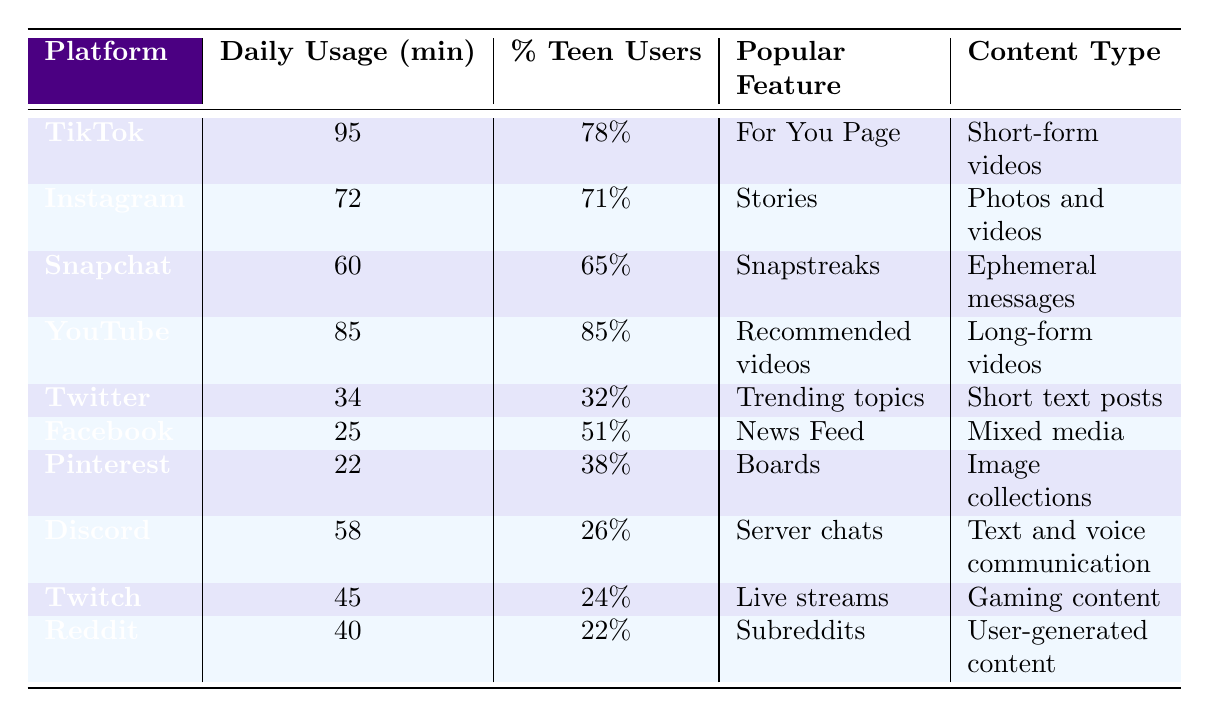What is the most popular social media platform among teenagers? The table shows that YouTube has the highest percentage of teenage users at 85%.
Answer: YouTube How many minutes do teenagers spend on Snapchat daily? According to the table, teenagers spend an average of 60 minutes on Snapchat each day.
Answer: 60 Which platform has the lowest average daily usage time? The table indicates that Facebook has the lowest average daily usage at 25 minutes.
Answer: Facebook What percentage of teenagers use Twitter? The table reveals that 32% of teenagers use Twitter.
Answer: 32% If we consider the top three social media platforms based on daily usage time, what is their average usage time? The average usage time is calculated as follows: (95 + 85 + 72) / 3 = 250 / 3 ≈ 83.33 minutes.
Answer: 83.33 minutes Is the primary content type for TikTok short-form videos? Yes, the table states that the primary content type for TikTok is indeed short-form videos.
Answer: Yes What is the difference in average daily usage between TikTok and Instagram? To find the difference, subtract Instagram's usage (72 minutes) from TikTok's usage (95 minutes): 95 - 72 = 23 minutes.
Answer: 23 minutes Which two platforms have a majority of teenage users (50% or more)? The platforms with more than 50% teenage users are YouTube (85%), TikTok (78%), Instagram (71%), and Facebook (51%).
Answer: YouTube, TikTok, Instagram, Facebook What feature is most popular on Pinterest? According to the table, the most popular feature on Pinterest is "Boards."
Answer: Boards Is Discord more popular than Twitch among teenagers? No, based on the percentage of teenage users, Discord has 26% while Twitch only has 24%.
Answer: No 